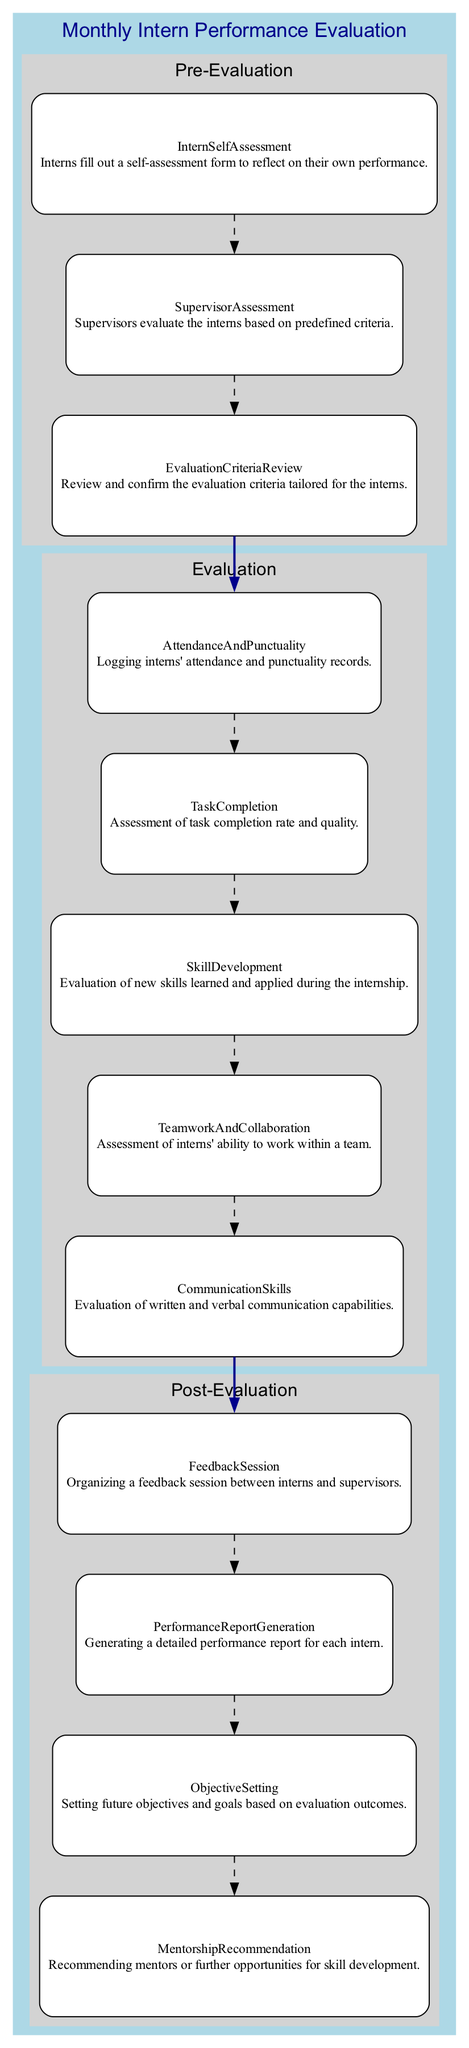what are the three main phases in the diagram? The three main phases depicted in the diagram are Pre-Evaluation, Evaluation, and Post-Evaluation. They are clearly separated and labeled within the structure of the block diagram.
Answer: Pre-Evaluation, Evaluation, Post-Evaluation how many elements are in the Evaluation phase? In the Evaluation phase, there are five elements listed: Attendance And Punctuality, Task Completion, Skill Development, Teamwork And Collaboration, and Communication Skills. By counting these, we confirm the total number of elements in this phase.
Answer: 5 what is the output of the Pre-Evaluation phase? The output after completing the Pre-Evaluation phase is the transition to the Evaluation phase. The last element in the Pre-Evaluation phase is Supervisor Assessment, which points to Attendance And Punctuality in the Evaluation phase.
Answer: Attendance And Punctuality which element assesses interns' communication capabilities? The element that evaluates interns' written and verbal communication capabilities is named Communication Skills, as indicated in the Evaluation phase. This element specifically focuses on assessing this aspect of intern performance.
Answer: Communication Skills what connects the last element of the Evaluation phase to the first element of the Post-Evaluation phase? The last element of the Evaluation phase is Communication Skills, and it connects to the first element of the Post-Evaluation phase, which is Feedback Session. This relationship shows the flow from evaluation to post-evaluation processes in the diagram.
Answer: Feedback Session how many elements are in total across all phases? The total number of elements can be calculated by summing up the individual elements in each of the three phases: Pre-Evaluation (3), Evaluation (5), and Post-Evaluation (4). Adding these gives 3 + 5 + 4 = 12 total elements in the entire diagram.
Answer: 12 what is the purpose of the Feedback Session? The Feedback Session serves as a venue for organizing discussions between interns and supervisors, facilitating the exchange of performance-related feedback. This description highlights the importance of this element within the Post-Evaluation phase.
Answer: Performance feedback which phase includes the element for evaluating skill development? The Evaluation phase contains the element specifically dedicated to assessing skill development during the internship. This is clearly defined as Skill Development in the diagram.
Answer: Evaluation phase 